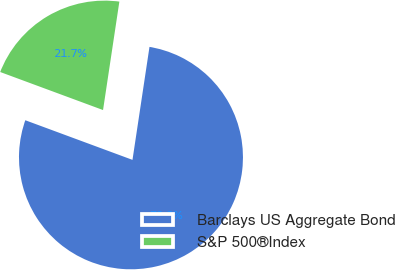<chart> <loc_0><loc_0><loc_500><loc_500><pie_chart><fcel>Barclays US Aggregate Bond<fcel>S&P 500®Index<nl><fcel>78.26%<fcel>21.74%<nl></chart> 